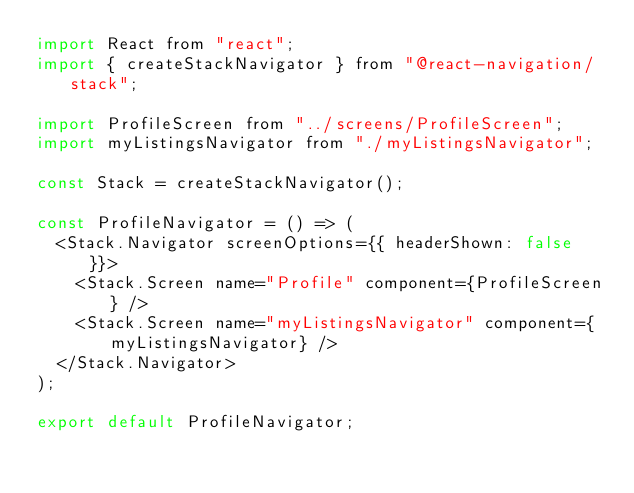Convert code to text. <code><loc_0><loc_0><loc_500><loc_500><_JavaScript_>import React from "react";
import { createStackNavigator } from "@react-navigation/stack";

import ProfileScreen from "../screens/ProfileScreen";
import myListingsNavigator from "./myListingsNavigator";

const Stack = createStackNavigator();

const ProfileNavigator = () => (
  <Stack.Navigator screenOptions={{ headerShown: false }}>
    <Stack.Screen name="Profile" component={ProfileScreen} />
    <Stack.Screen name="myListingsNavigator" component={myListingsNavigator} />
  </Stack.Navigator>
);

export default ProfileNavigator;
</code> 